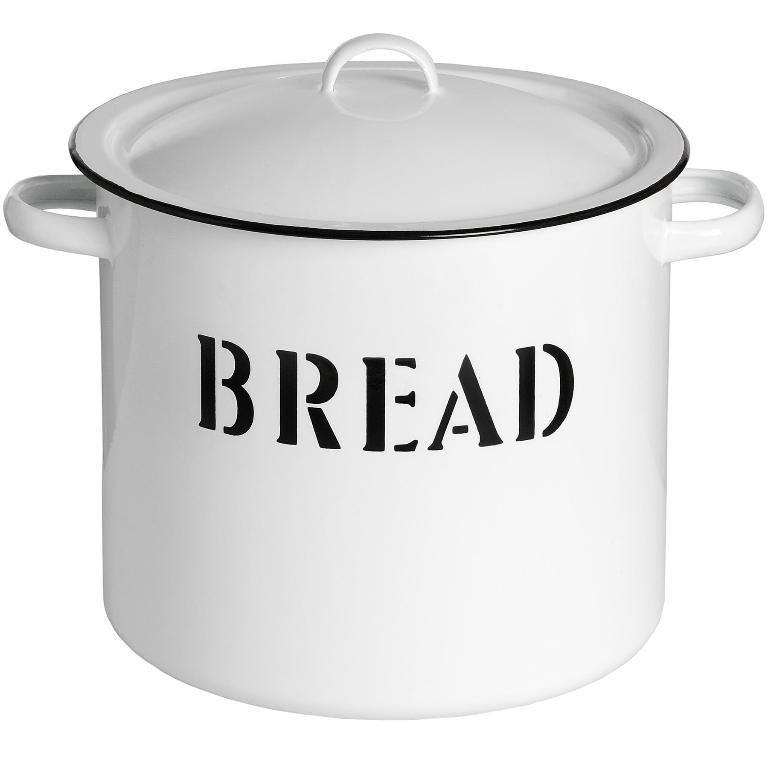<image>
Share a concise interpretation of the image provided. The large porcelain pot and lid were specifically designed and labelled for bread. 